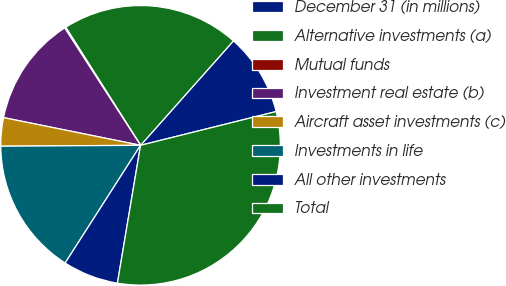Convert chart to OTSL. <chart><loc_0><loc_0><loc_500><loc_500><pie_chart><fcel>December 31 (in millions)<fcel>Alternative investments (a)<fcel>Mutual funds<fcel>Investment real estate (b)<fcel>Aircraft asset investments (c)<fcel>Investments in life<fcel>All other investments<fcel>Total<nl><fcel>9.55%<fcel>20.56%<fcel>0.14%<fcel>12.69%<fcel>3.28%<fcel>15.83%<fcel>6.42%<fcel>31.53%<nl></chart> 